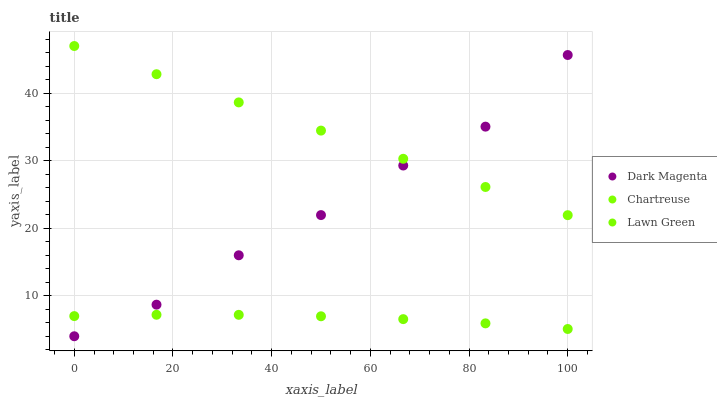Does Lawn Green have the minimum area under the curve?
Answer yes or no. Yes. Does Chartreuse have the maximum area under the curve?
Answer yes or no. Yes. Does Dark Magenta have the minimum area under the curve?
Answer yes or no. No. Does Dark Magenta have the maximum area under the curve?
Answer yes or no. No. Is Chartreuse the smoothest?
Answer yes or no. Yes. Is Dark Magenta the roughest?
Answer yes or no. Yes. Is Dark Magenta the smoothest?
Answer yes or no. No. Is Chartreuse the roughest?
Answer yes or no. No. Does Dark Magenta have the lowest value?
Answer yes or no. Yes. Does Chartreuse have the lowest value?
Answer yes or no. No. Does Chartreuse have the highest value?
Answer yes or no. Yes. Does Dark Magenta have the highest value?
Answer yes or no. No. Is Lawn Green less than Chartreuse?
Answer yes or no. Yes. Is Chartreuse greater than Lawn Green?
Answer yes or no. Yes. Does Lawn Green intersect Dark Magenta?
Answer yes or no. Yes. Is Lawn Green less than Dark Magenta?
Answer yes or no. No. Is Lawn Green greater than Dark Magenta?
Answer yes or no. No. Does Lawn Green intersect Chartreuse?
Answer yes or no. No. 